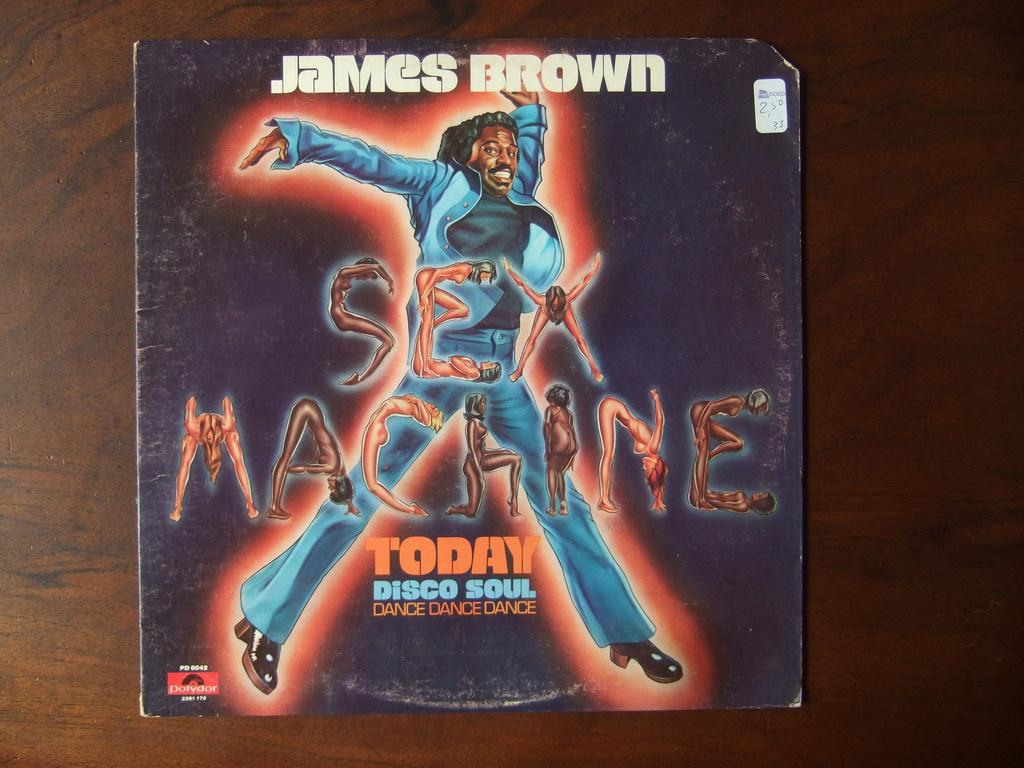<image>
Give a short and clear explanation of the subsequent image. Old album of Jame Brown's Sex Machine cover. 